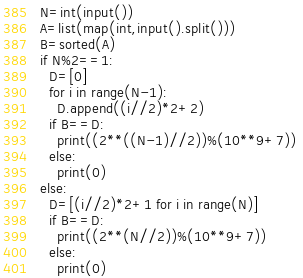Convert code to text. <code><loc_0><loc_0><loc_500><loc_500><_Python_>N=int(input())
A=list(map(int,input().split()))
B=sorted(A)
if N%2==1:
  D=[0]
  for i in range(N-1):
    D.append((i//2)*2+2)
  if B==D:
    print((2**((N-1)//2))%(10**9+7)) 
  else:
    print(0)
else:
  D=[(i//2)*2+1 for i in range(N)]
  if B==D:
    print((2**(N//2))%(10**9+7))
  else:
    print(0)</code> 